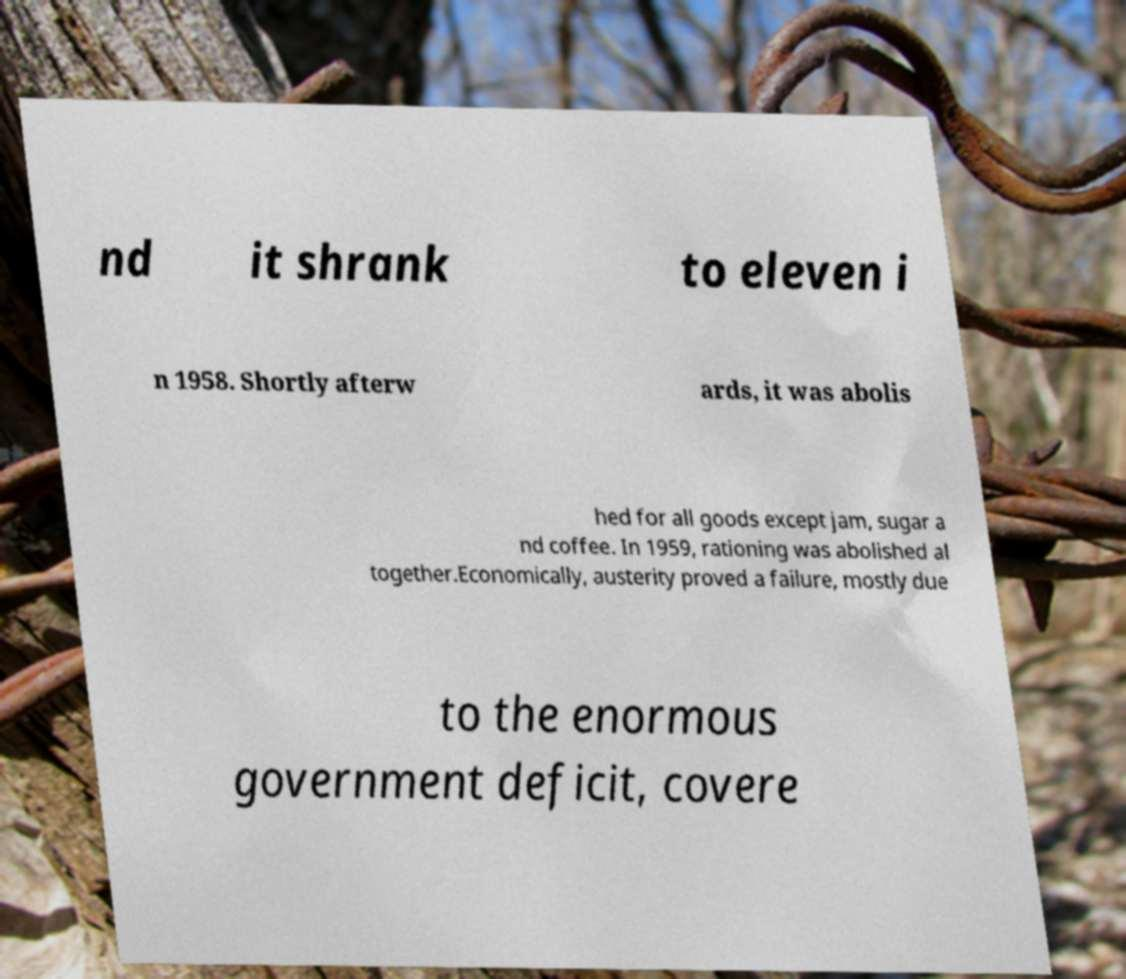Can you accurately transcribe the text from the provided image for me? nd it shrank to eleven i n 1958. Shortly afterw ards, it was abolis hed for all goods except jam, sugar a nd coffee. In 1959, rationing was abolished al together.Economically, austerity proved a failure, mostly due to the enormous government deficit, covere 